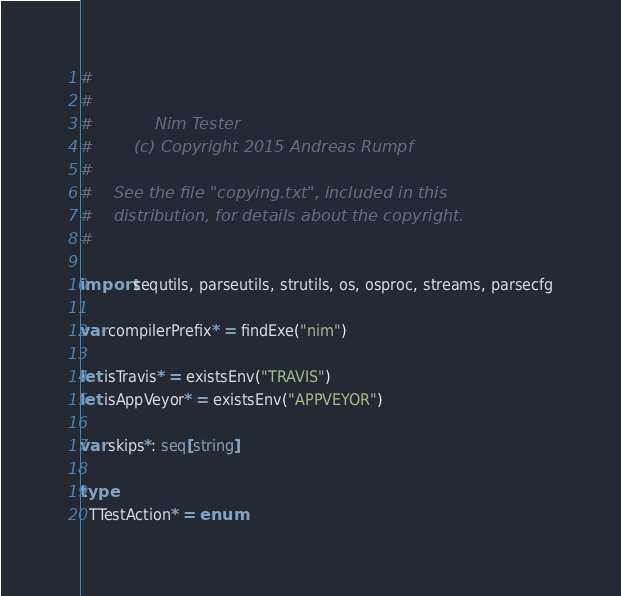<code> <loc_0><loc_0><loc_500><loc_500><_Nim_>#
#
#            Nim Tester
#        (c) Copyright 2015 Andreas Rumpf
#
#    See the file "copying.txt", included in this
#    distribution, for details about the copyright.
#

import sequtils, parseutils, strutils, os, osproc, streams, parsecfg

var compilerPrefix* = findExe("nim")

let isTravis* = existsEnv("TRAVIS")
let isAppVeyor* = existsEnv("APPVEYOR")

var skips*: seq[string]

type
  TTestAction* = enum</code> 